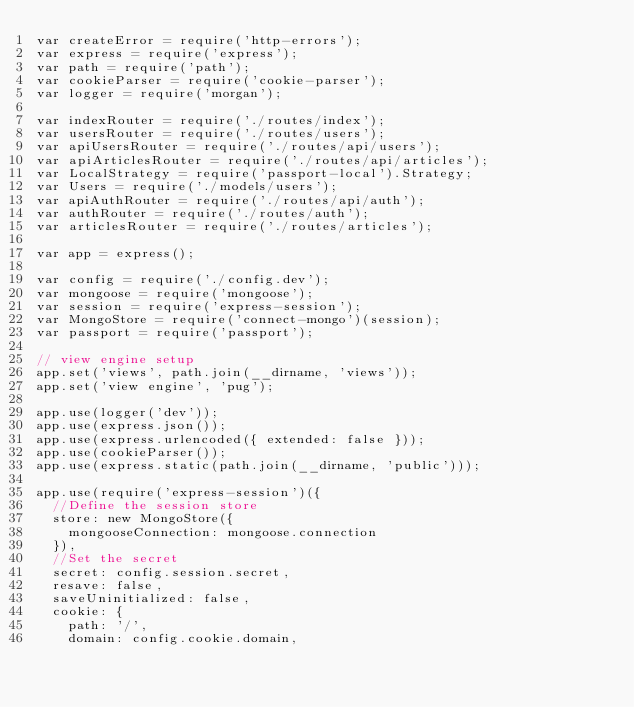<code> <loc_0><loc_0><loc_500><loc_500><_JavaScript_>var createError = require('http-errors');
var express = require('express');
var path = require('path');
var cookieParser = require('cookie-parser');
var logger = require('morgan');

var indexRouter = require('./routes/index');
var usersRouter = require('./routes/users');
var apiUsersRouter = require('./routes/api/users');
var apiArticlesRouter = require('./routes/api/articles');
var LocalStrategy = require('passport-local').Strategy;
var Users = require('./models/users');
var apiAuthRouter = require('./routes/api/auth');
var authRouter = require('./routes/auth');
var articlesRouter = require('./routes/articles');

var app = express();

var config = require('./config.dev');
var mongoose = require('mongoose');
var session = require('express-session');
var MongoStore = require('connect-mongo')(session);
var passport = require('passport');

// view engine setup
app.set('views', path.join(__dirname, 'views'));
app.set('view engine', 'pug');

app.use(logger('dev'));
app.use(express.json());
app.use(express.urlencoded({ extended: false }));
app.use(cookieParser());
app.use(express.static(path.join(__dirname, 'public')));

app.use(require('express-session')({
  //Define the session store
  store: new MongoStore({
    mongooseConnection: mongoose.connection
  }),
  //Set the secret
  secret: config.session.secret,
  resave: false,
  saveUninitialized: false,
  cookie: {
    path: '/',
    domain: config.cookie.domain,</code> 